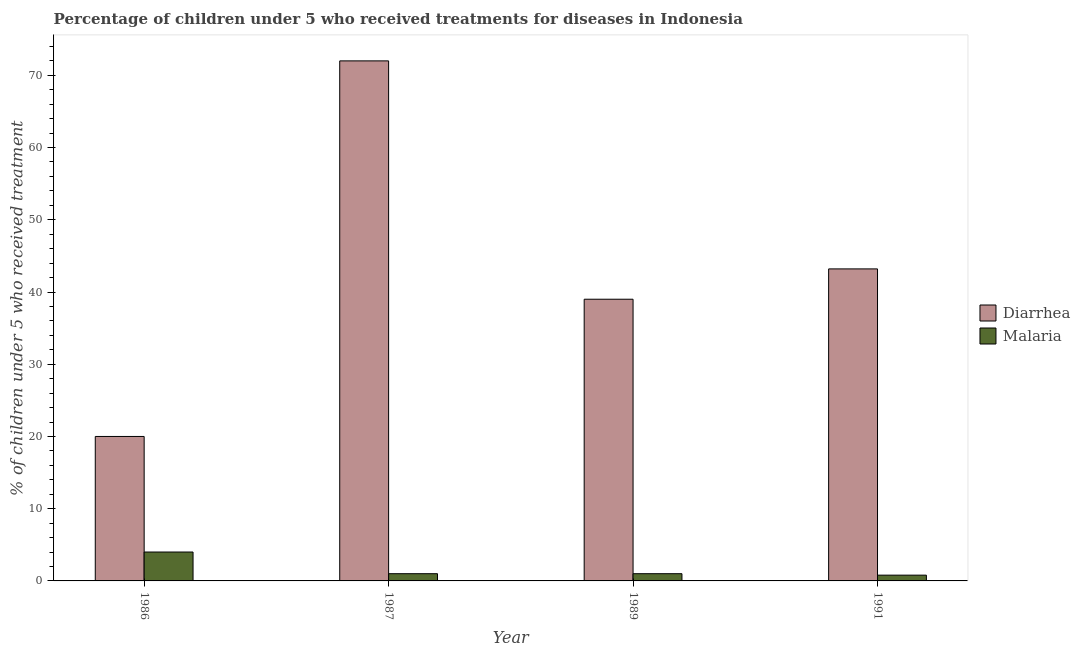How many different coloured bars are there?
Your answer should be very brief. 2. Are the number of bars per tick equal to the number of legend labels?
Your answer should be compact. Yes. Are the number of bars on each tick of the X-axis equal?
Your answer should be compact. Yes. How many bars are there on the 3rd tick from the left?
Your response must be concise. 2. What is the label of the 2nd group of bars from the left?
Make the answer very short. 1987. Across all years, what is the maximum percentage of children who received treatment for diarrhoea?
Offer a very short reply. 72. What is the total percentage of children who received treatment for diarrhoea in the graph?
Provide a short and direct response. 174.2. What is the difference between the percentage of children who received treatment for diarrhoea in 1986 and that in 1987?
Keep it short and to the point. -52. In how many years, is the percentage of children who received treatment for malaria greater than 68 %?
Ensure brevity in your answer.  0. Is the percentage of children who received treatment for diarrhoea in 1986 less than that in 1987?
Your answer should be very brief. Yes. Is the difference between the percentage of children who received treatment for malaria in 1986 and 1989 greater than the difference between the percentage of children who received treatment for diarrhoea in 1986 and 1989?
Offer a terse response. No. What is the difference between the highest and the second highest percentage of children who received treatment for diarrhoea?
Your response must be concise. 28.8. What is the difference between the highest and the lowest percentage of children who received treatment for malaria?
Offer a terse response. 3.2. In how many years, is the percentage of children who received treatment for diarrhoea greater than the average percentage of children who received treatment for diarrhoea taken over all years?
Make the answer very short. 1. Is the sum of the percentage of children who received treatment for malaria in 1989 and 1991 greater than the maximum percentage of children who received treatment for diarrhoea across all years?
Provide a short and direct response. No. What does the 1st bar from the left in 1986 represents?
Offer a terse response. Diarrhea. What does the 2nd bar from the right in 1987 represents?
Your answer should be very brief. Diarrhea. Are all the bars in the graph horizontal?
Provide a short and direct response. No. How many years are there in the graph?
Keep it short and to the point. 4. What is the difference between two consecutive major ticks on the Y-axis?
Make the answer very short. 10. Are the values on the major ticks of Y-axis written in scientific E-notation?
Ensure brevity in your answer.  No. Does the graph contain grids?
Your answer should be compact. No. Where does the legend appear in the graph?
Ensure brevity in your answer.  Center right. What is the title of the graph?
Your response must be concise. Percentage of children under 5 who received treatments for diseases in Indonesia. What is the label or title of the Y-axis?
Keep it short and to the point. % of children under 5 who received treatment. What is the % of children under 5 who received treatment of Diarrhea in 1986?
Your answer should be compact. 20. What is the % of children under 5 who received treatment in Malaria in 1987?
Give a very brief answer. 1. What is the % of children under 5 who received treatment of Diarrhea in 1989?
Give a very brief answer. 39. What is the % of children under 5 who received treatment in Malaria in 1989?
Give a very brief answer. 1. What is the % of children under 5 who received treatment in Diarrhea in 1991?
Provide a succinct answer. 43.2. What is the % of children under 5 who received treatment in Malaria in 1991?
Offer a very short reply. 0.8. Across all years, what is the maximum % of children under 5 who received treatment of Diarrhea?
Give a very brief answer. 72. Across all years, what is the maximum % of children under 5 who received treatment of Malaria?
Provide a short and direct response. 4. What is the total % of children under 5 who received treatment in Diarrhea in the graph?
Your answer should be very brief. 174.2. What is the total % of children under 5 who received treatment in Malaria in the graph?
Your response must be concise. 6.8. What is the difference between the % of children under 5 who received treatment in Diarrhea in 1986 and that in 1987?
Give a very brief answer. -52. What is the difference between the % of children under 5 who received treatment in Malaria in 1986 and that in 1987?
Provide a succinct answer. 3. What is the difference between the % of children under 5 who received treatment of Diarrhea in 1986 and that in 1989?
Ensure brevity in your answer.  -19. What is the difference between the % of children under 5 who received treatment in Malaria in 1986 and that in 1989?
Your answer should be compact. 3. What is the difference between the % of children under 5 who received treatment in Diarrhea in 1986 and that in 1991?
Provide a succinct answer. -23.2. What is the difference between the % of children under 5 who received treatment of Malaria in 1986 and that in 1991?
Your response must be concise. 3.2. What is the difference between the % of children under 5 who received treatment in Diarrhea in 1987 and that in 1989?
Keep it short and to the point. 33. What is the difference between the % of children under 5 who received treatment of Diarrhea in 1987 and that in 1991?
Provide a succinct answer. 28.8. What is the difference between the % of children under 5 who received treatment of Malaria in 1987 and that in 1991?
Make the answer very short. 0.2. What is the difference between the % of children under 5 who received treatment of Diarrhea in 1989 and that in 1991?
Keep it short and to the point. -4.2. What is the difference between the % of children under 5 who received treatment in Malaria in 1989 and that in 1991?
Provide a succinct answer. 0.2. What is the difference between the % of children under 5 who received treatment of Diarrhea in 1986 and the % of children under 5 who received treatment of Malaria in 1989?
Your answer should be compact. 19. What is the difference between the % of children under 5 who received treatment of Diarrhea in 1986 and the % of children under 5 who received treatment of Malaria in 1991?
Your answer should be very brief. 19.2. What is the difference between the % of children under 5 who received treatment of Diarrhea in 1987 and the % of children under 5 who received treatment of Malaria in 1989?
Offer a terse response. 71. What is the difference between the % of children under 5 who received treatment in Diarrhea in 1987 and the % of children under 5 who received treatment in Malaria in 1991?
Your answer should be compact. 71.2. What is the difference between the % of children under 5 who received treatment of Diarrhea in 1989 and the % of children under 5 who received treatment of Malaria in 1991?
Offer a terse response. 38.2. What is the average % of children under 5 who received treatment in Diarrhea per year?
Ensure brevity in your answer.  43.55. What is the average % of children under 5 who received treatment in Malaria per year?
Give a very brief answer. 1.7. In the year 1986, what is the difference between the % of children under 5 who received treatment of Diarrhea and % of children under 5 who received treatment of Malaria?
Your answer should be compact. 16. In the year 1987, what is the difference between the % of children under 5 who received treatment of Diarrhea and % of children under 5 who received treatment of Malaria?
Your response must be concise. 71. In the year 1991, what is the difference between the % of children under 5 who received treatment in Diarrhea and % of children under 5 who received treatment in Malaria?
Give a very brief answer. 42.4. What is the ratio of the % of children under 5 who received treatment of Diarrhea in 1986 to that in 1987?
Offer a very short reply. 0.28. What is the ratio of the % of children under 5 who received treatment of Diarrhea in 1986 to that in 1989?
Make the answer very short. 0.51. What is the ratio of the % of children under 5 who received treatment in Diarrhea in 1986 to that in 1991?
Offer a very short reply. 0.46. What is the ratio of the % of children under 5 who received treatment in Malaria in 1986 to that in 1991?
Make the answer very short. 5. What is the ratio of the % of children under 5 who received treatment of Diarrhea in 1987 to that in 1989?
Your response must be concise. 1.85. What is the ratio of the % of children under 5 who received treatment of Malaria in 1987 to that in 1989?
Your answer should be compact. 1. What is the ratio of the % of children under 5 who received treatment in Malaria in 1987 to that in 1991?
Your response must be concise. 1.25. What is the ratio of the % of children under 5 who received treatment of Diarrhea in 1989 to that in 1991?
Offer a very short reply. 0.9. What is the ratio of the % of children under 5 who received treatment in Malaria in 1989 to that in 1991?
Offer a very short reply. 1.25. What is the difference between the highest and the second highest % of children under 5 who received treatment in Diarrhea?
Offer a very short reply. 28.8. What is the difference between the highest and the second highest % of children under 5 who received treatment of Malaria?
Provide a succinct answer. 3. What is the difference between the highest and the lowest % of children under 5 who received treatment in Diarrhea?
Provide a short and direct response. 52. What is the difference between the highest and the lowest % of children under 5 who received treatment of Malaria?
Keep it short and to the point. 3.2. 